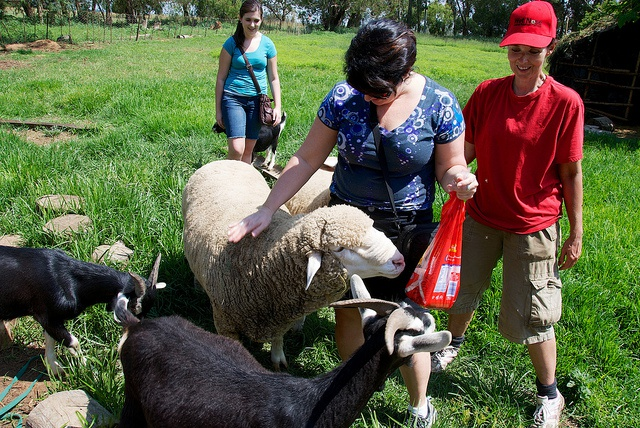Describe the objects in this image and their specific colors. I can see people in black, lightgray, gray, and maroon tones, people in black, maroon, brown, and salmon tones, sheep in black, gray, and lightgray tones, sheep in black, lightgray, gray, and darkgray tones, and sheep in black, gray, and blue tones in this image. 